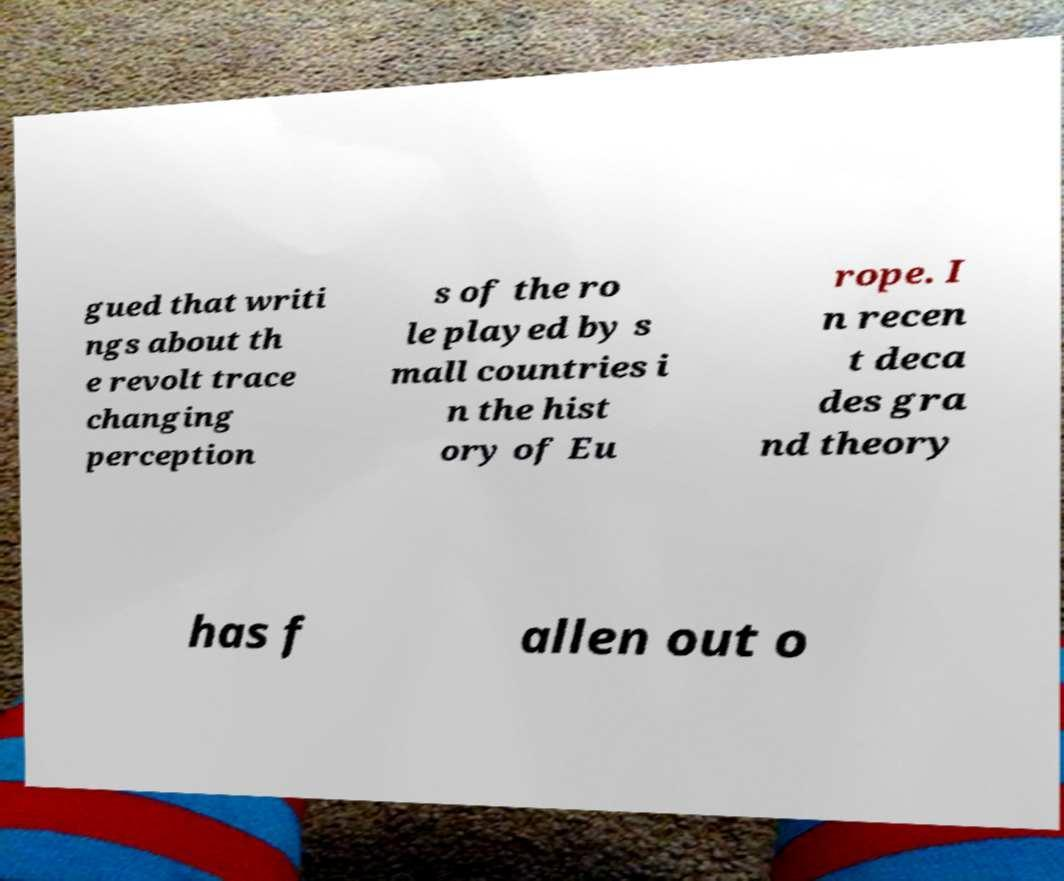Could you assist in decoding the text presented in this image and type it out clearly? gued that writi ngs about th e revolt trace changing perception s of the ro le played by s mall countries i n the hist ory of Eu rope. I n recen t deca des gra nd theory has f allen out o 